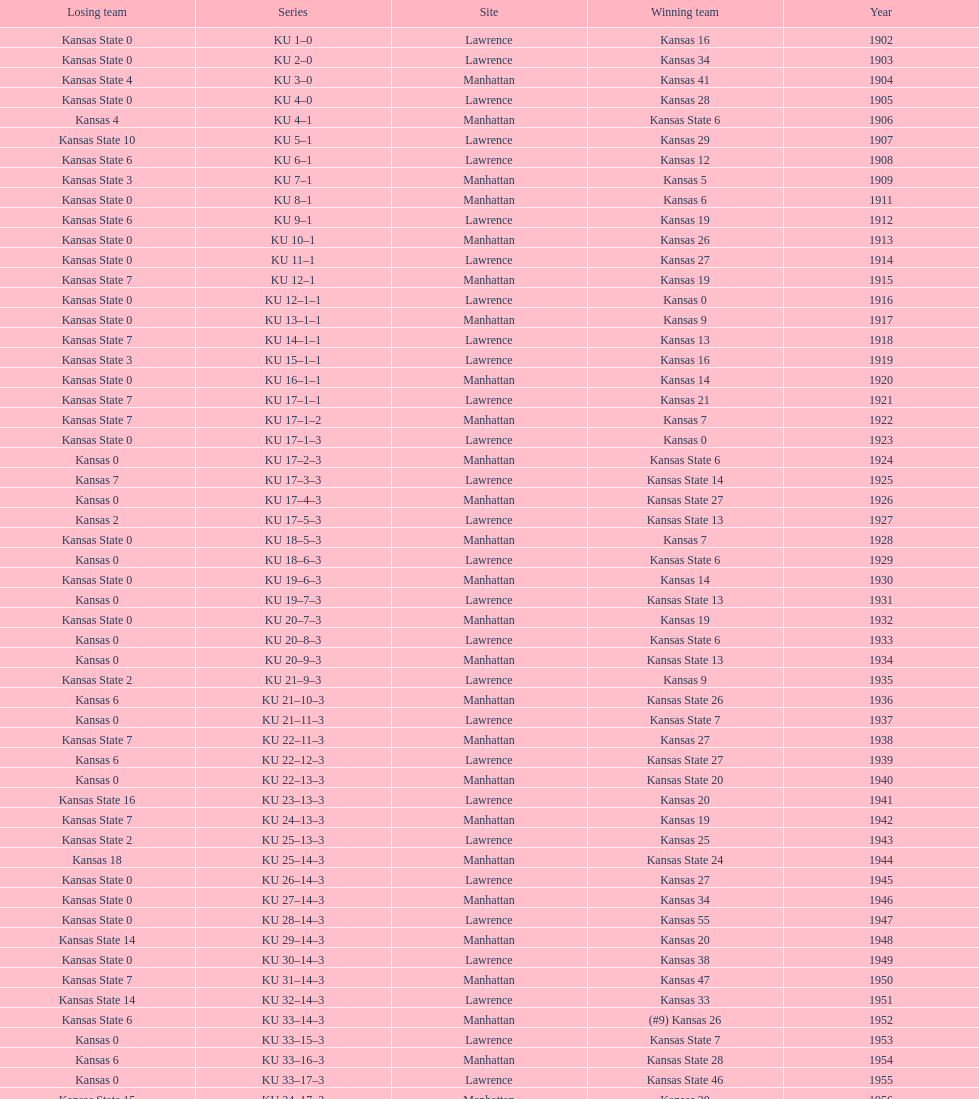How many times did kansas beat kansas state before 1910? 7. 